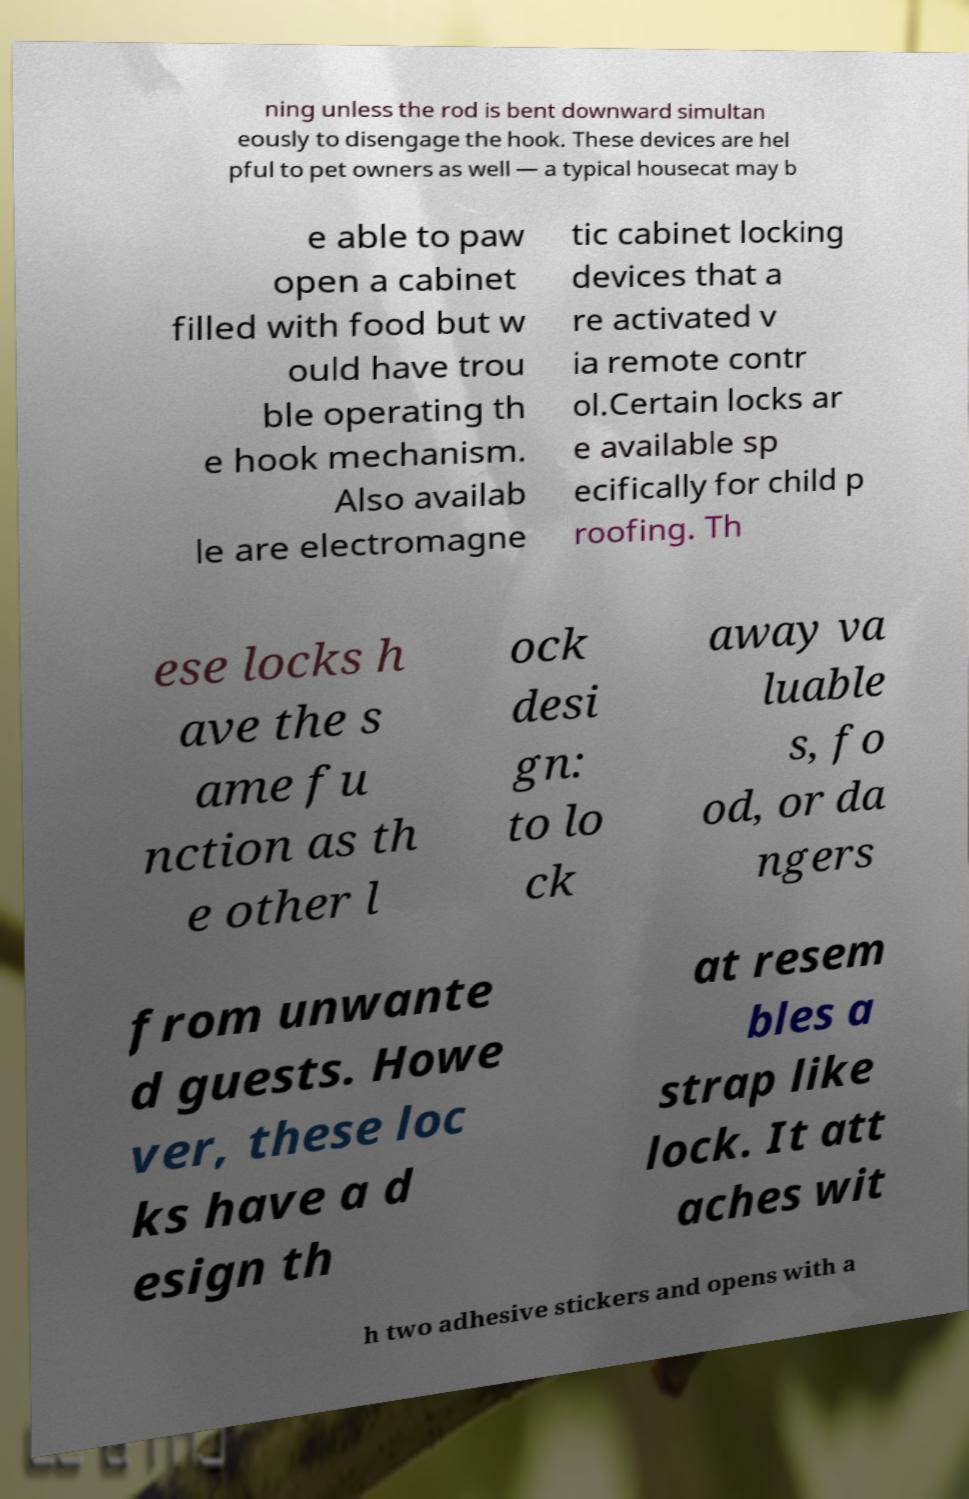Could you extract and type out the text from this image? ning unless the rod is bent downward simultan eously to disengage the hook. These devices are hel pful to pet owners as well — a typical housecat may b e able to paw open a cabinet filled with food but w ould have trou ble operating th e hook mechanism. Also availab le are electromagne tic cabinet locking devices that a re activated v ia remote contr ol.Certain locks ar e available sp ecifically for child p roofing. Th ese locks h ave the s ame fu nction as th e other l ock desi gn: to lo ck away va luable s, fo od, or da ngers from unwante d guests. Howe ver, these loc ks have a d esign th at resem bles a strap like lock. It att aches wit h two adhesive stickers and opens with a 